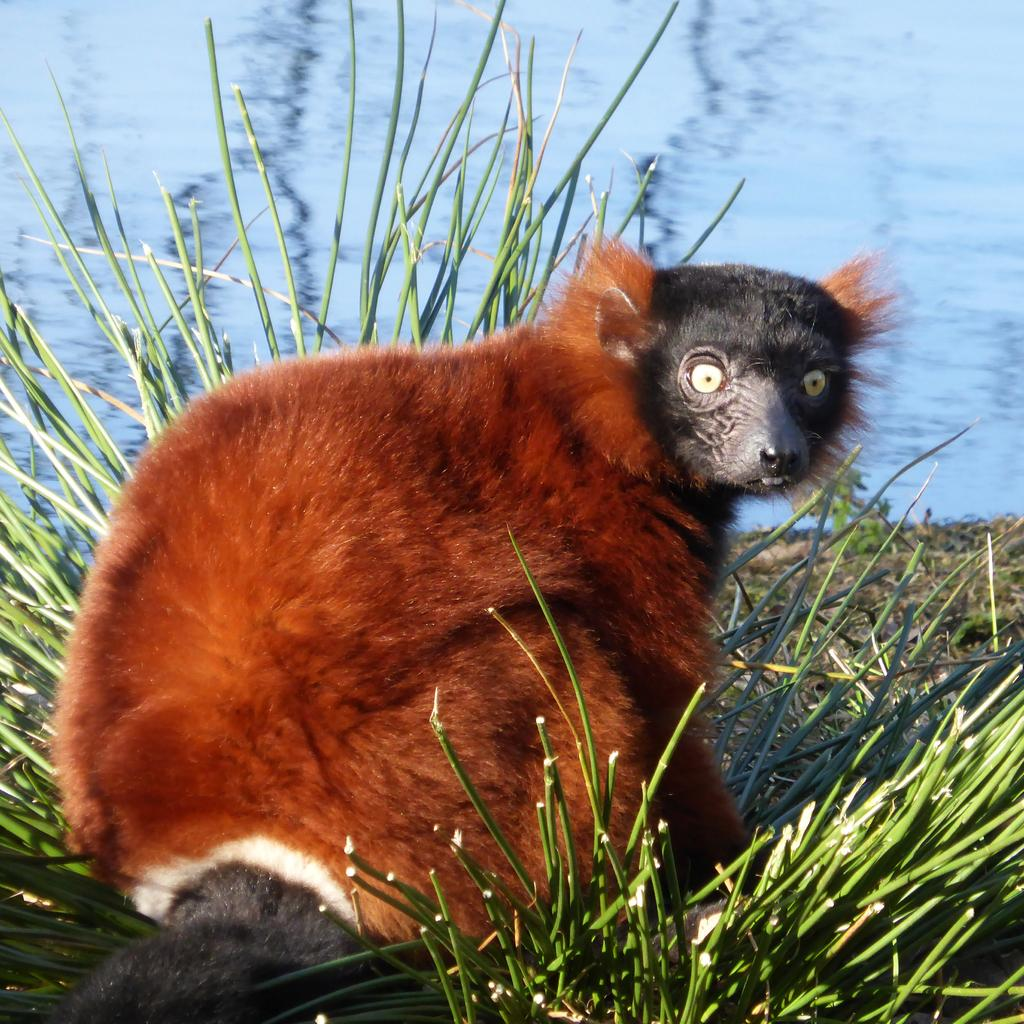What type of animal can be seen in the image? There is an animal in the image, but its specific type cannot be determined from the provided facts. What colors are present on the animal? The animal has brown and black colors. What type of vegetation is near the animal? There is grass beside the animal. What can be seen in the distance in the image? There is water visible in the background of the image. What type of knee injury is the animal suffering from in the image? There is no indication of any injury, including a knee injury, in the image. 